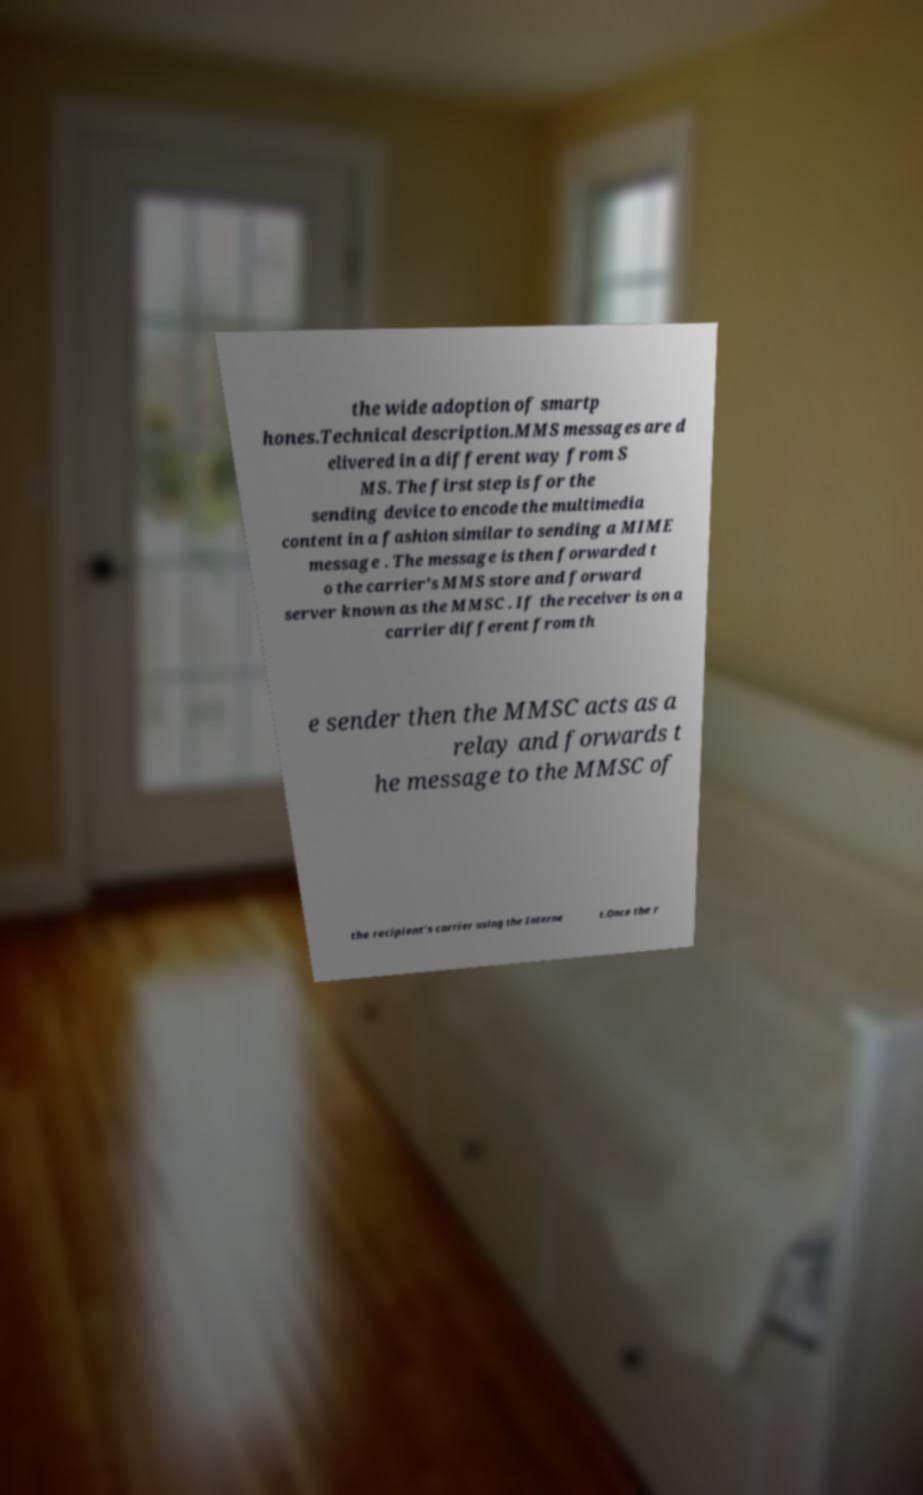What messages or text are displayed in this image? I need them in a readable, typed format. the wide adoption of smartp hones.Technical description.MMS messages are d elivered in a different way from S MS. The first step is for the sending device to encode the multimedia content in a fashion similar to sending a MIME message . The message is then forwarded t o the carrier's MMS store and forward server known as the MMSC . If the receiver is on a carrier different from th e sender then the MMSC acts as a relay and forwards t he message to the MMSC of the recipient's carrier using the Interne t.Once the r 